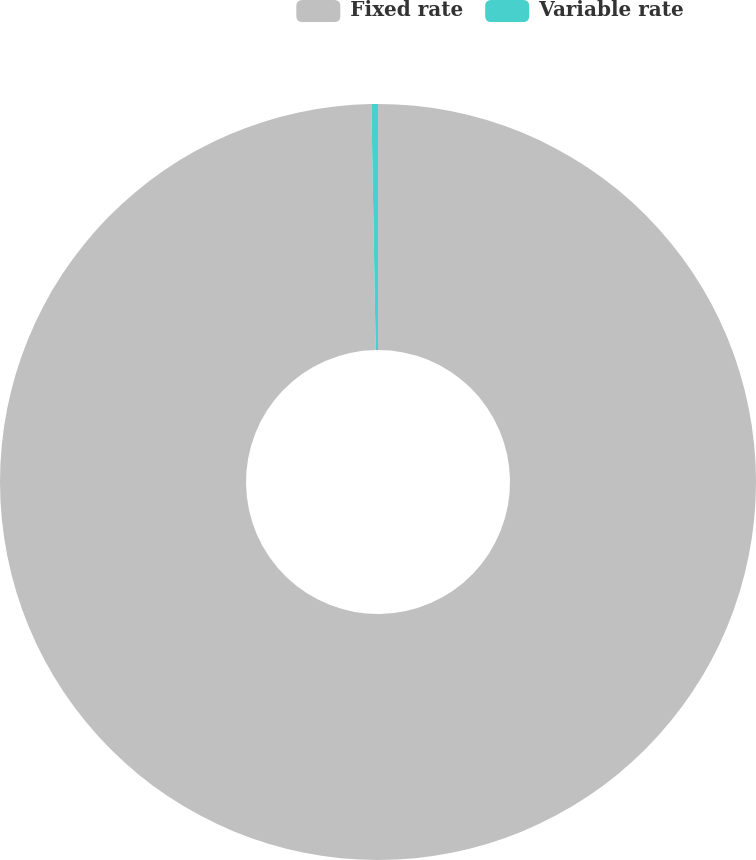<chart> <loc_0><loc_0><loc_500><loc_500><pie_chart><fcel>Fixed rate<fcel>Variable rate<nl><fcel>99.72%<fcel>0.28%<nl></chart> 